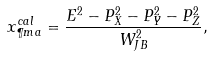<formula> <loc_0><loc_0><loc_500><loc_500>x ^ { c a l } _ { \P m a } = \frac { E ^ { 2 } - P _ { X } ^ { 2 } - P _ { Y } ^ { 2 } - P _ { Z } ^ { 2 } } { W ^ { 2 } _ { J B } } ,</formula> 